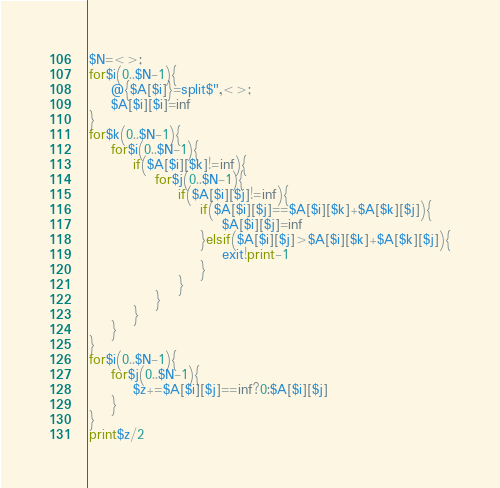Convert code to text. <code><loc_0><loc_0><loc_500><loc_500><_Perl_>$N=<>;
for$i(0..$N-1){
	@{$A[$i]}=split$",<>;
	$A[$i][$i]=inf
}
for$k(0..$N-1){
	for$i(0..$N-1){
		if($A[$i][$k]!=inf){
			for$j(0..$N-1){
				if($A[$i][$j]!=inf){
					if($A[$i][$j]==$A[$i][$k]+$A[$k][$j]){
						$A[$i][$j]=inf
					}elsif($A[$i][$j]>$A[$i][$k]+$A[$k][$j]){
						exit!print-1
					}
				}
			}
		}
	}
}
for$i(0..$N-1){
	for$j(0..$N-1){
		$z+=$A[$i][$j]==inf?0:$A[$i][$j]
	}
}
print$z/2
</code> 